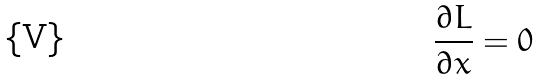<formula> <loc_0><loc_0><loc_500><loc_500>\frac { \partial L } { \partial x } = 0</formula> 